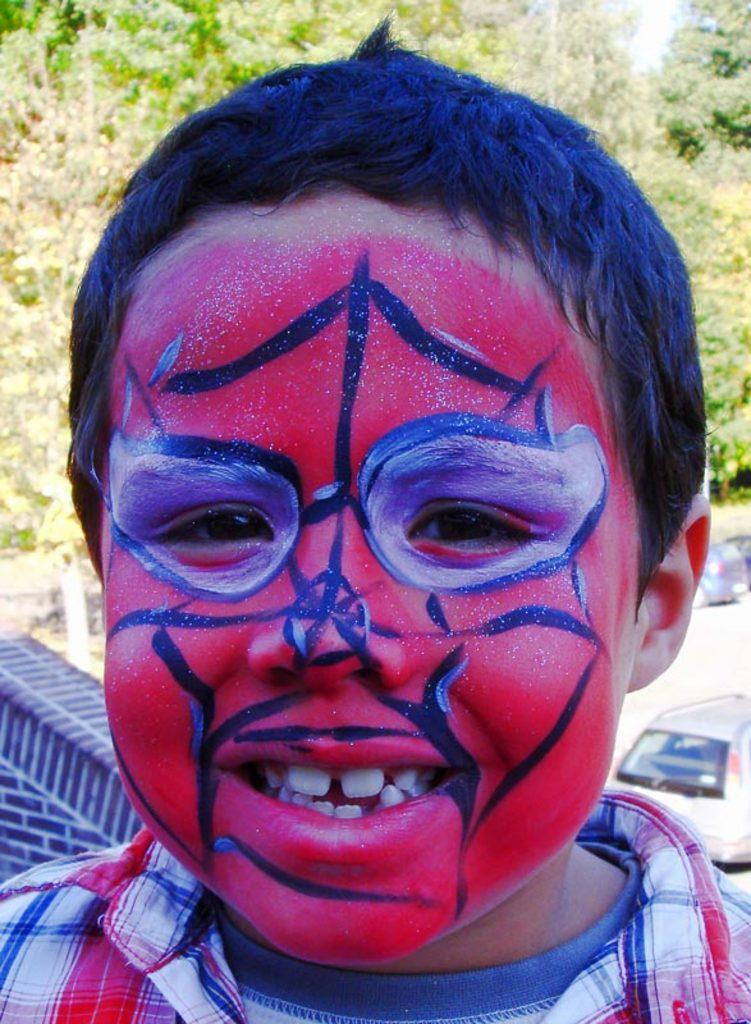Who is the main subject in the image? There is a boy in the center of the image. What is located in the middle of the image? Cars and a road are present in the middle of the image. What type of vegetation can be seen at the top of the image? Trees are present at the top of the image. Can you see a frog forming a slippery surface on the road in the image? No, there is no frog or slippery surface on the road in the image. 